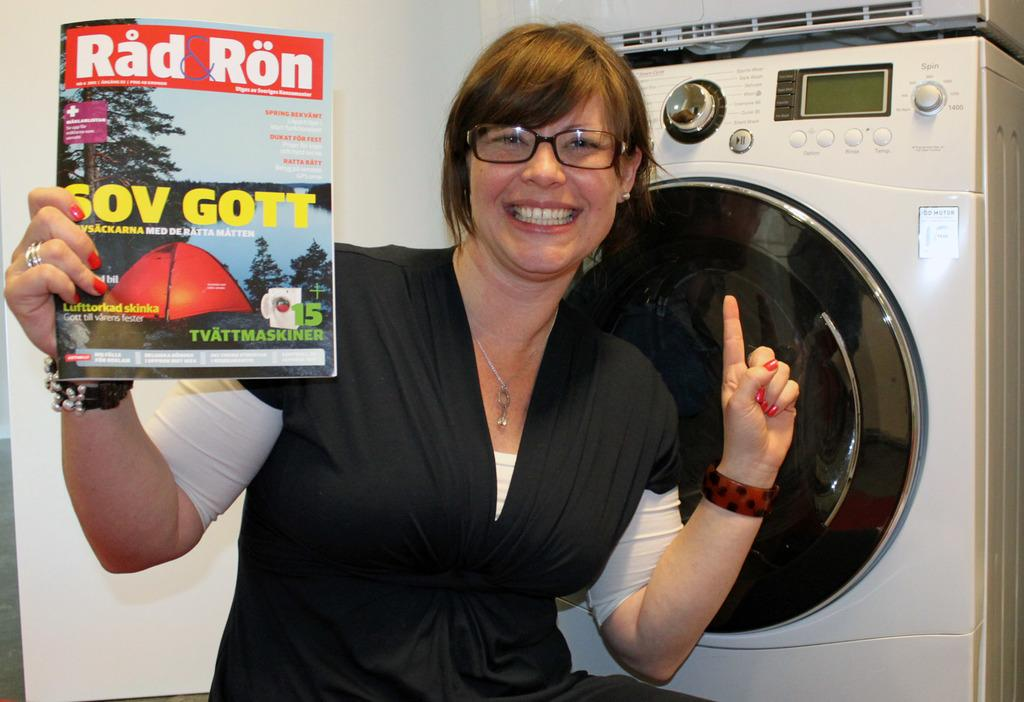<image>
Give a short and clear explanation of the subsequent image. a lady with glasses holding onto a Rad Ron magazine 